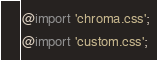Convert code to text. <code><loc_0><loc_0><loc_500><loc_500><_CSS_>@import 'chroma.css';
@import 'custom.css';

</code> 